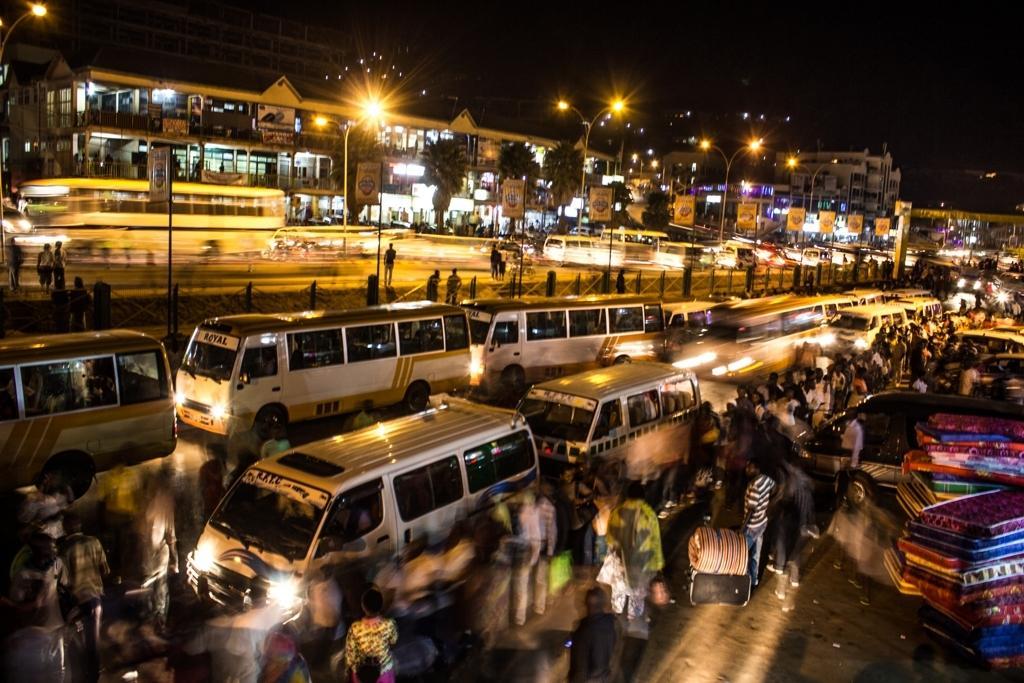Describe this image in one or two sentences. In this picture I can see mattresses one upon the another on the path, there are group of people, vehicles on the road, there are boards, poles, lights, trees, buildings, and in the background there is sky. 